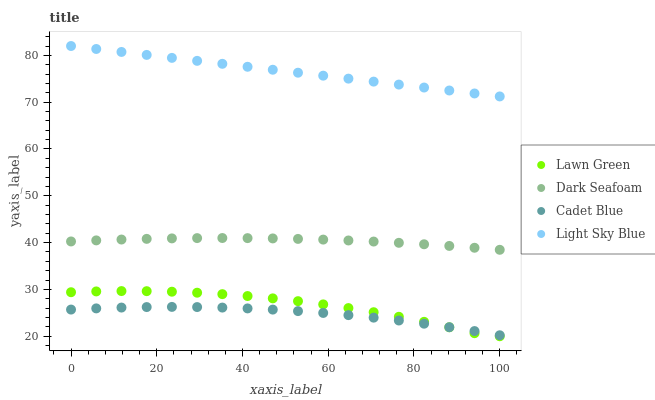Does Cadet Blue have the minimum area under the curve?
Answer yes or no. Yes. Does Light Sky Blue have the maximum area under the curve?
Answer yes or no. Yes. Does Dark Seafoam have the minimum area under the curve?
Answer yes or no. No. Does Dark Seafoam have the maximum area under the curve?
Answer yes or no. No. Is Light Sky Blue the smoothest?
Answer yes or no. Yes. Is Lawn Green the roughest?
Answer yes or no. Yes. Is Dark Seafoam the smoothest?
Answer yes or no. No. Is Dark Seafoam the roughest?
Answer yes or no. No. Does Lawn Green have the lowest value?
Answer yes or no. Yes. Does Dark Seafoam have the lowest value?
Answer yes or no. No. Does Light Sky Blue have the highest value?
Answer yes or no. Yes. Does Dark Seafoam have the highest value?
Answer yes or no. No. Is Cadet Blue less than Light Sky Blue?
Answer yes or no. Yes. Is Dark Seafoam greater than Cadet Blue?
Answer yes or no. Yes. Does Lawn Green intersect Cadet Blue?
Answer yes or no. Yes. Is Lawn Green less than Cadet Blue?
Answer yes or no. No. Is Lawn Green greater than Cadet Blue?
Answer yes or no. No. Does Cadet Blue intersect Light Sky Blue?
Answer yes or no. No. 